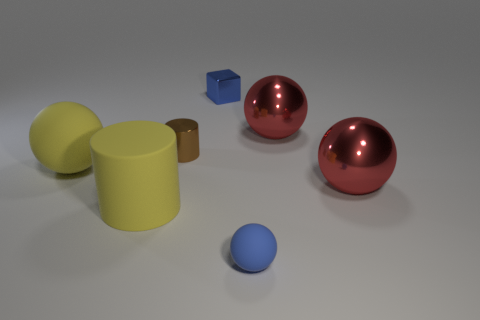How many other things are the same size as the yellow ball?
Provide a succinct answer. 3. What number of things are behind the tiny blue matte thing and to the right of the big yellow sphere?
Ensure brevity in your answer.  5. Is the number of large metal things greater than the number of yellow matte cylinders?
Provide a succinct answer. Yes. What is the material of the cube?
Offer a terse response. Metal. There is a big red shiny sphere that is in front of the yellow matte ball; what number of large yellow cylinders are to the left of it?
Your answer should be compact. 1. There is a block; is its color the same as the small object in front of the small brown thing?
Offer a terse response. Yes. There is a sphere that is the same size as the blue metal block; what is its color?
Offer a terse response. Blue. Are there any big red metallic things of the same shape as the brown shiny thing?
Make the answer very short. No. Is the number of blue rubber balls less than the number of large purple shiny cylinders?
Keep it short and to the point. No. There is a big ball on the left side of the small blue ball; what color is it?
Make the answer very short. Yellow. 